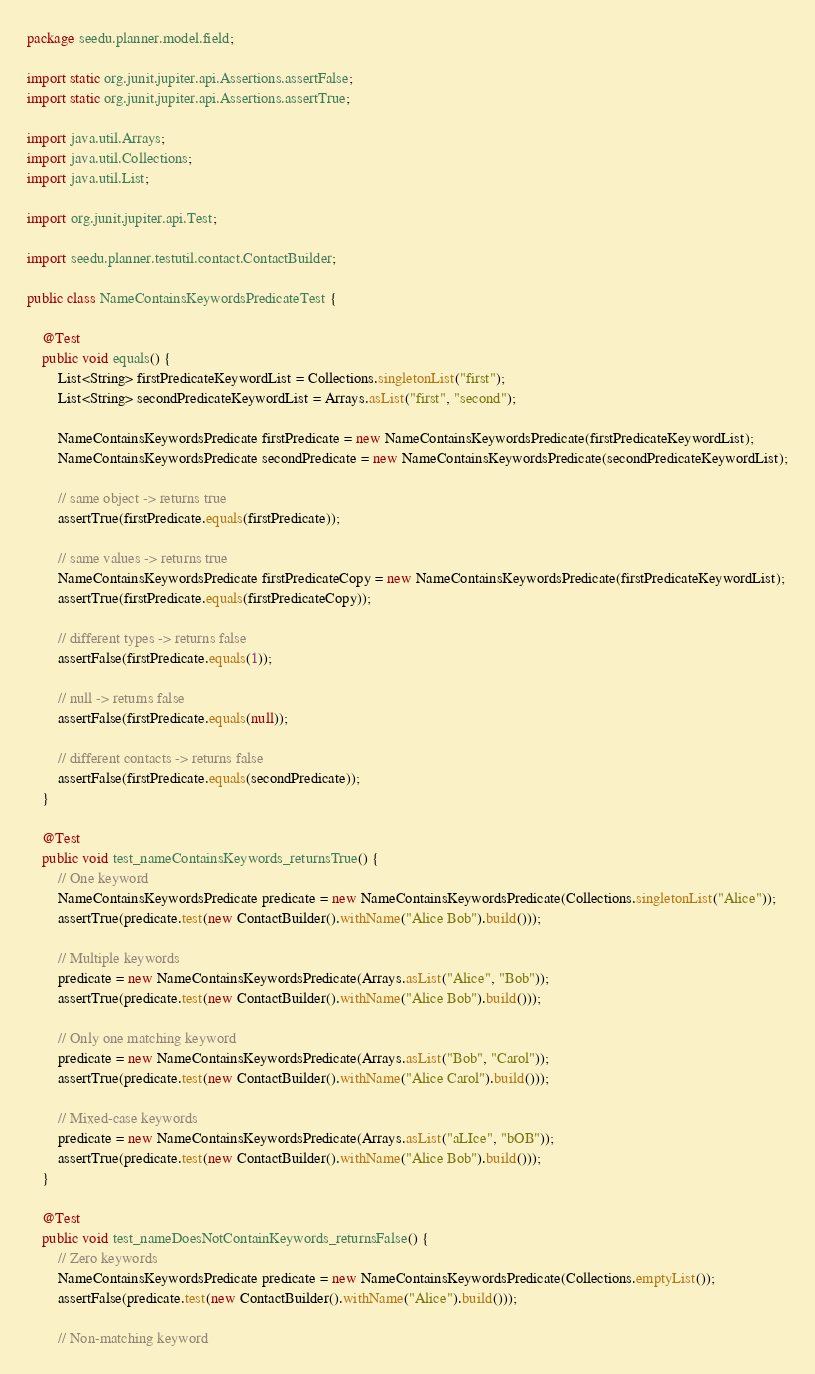Convert code to text. <code><loc_0><loc_0><loc_500><loc_500><_Java_>package seedu.planner.model.field;

import static org.junit.jupiter.api.Assertions.assertFalse;
import static org.junit.jupiter.api.Assertions.assertTrue;

import java.util.Arrays;
import java.util.Collections;
import java.util.List;

import org.junit.jupiter.api.Test;

import seedu.planner.testutil.contact.ContactBuilder;

public class NameContainsKeywordsPredicateTest {

    @Test
    public void equals() {
        List<String> firstPredicateKeywordList = Collections.singletonList("first");
        List<String> secondPredicateKeywordList = Arrays.asList("first", "second");

        NameContainsKeywordsPredicate firstPredicate = new NameContainsKeywordsPredicate(firstPredicateKeywordList);
        NameContainsKeywordsPredicate secondPredicate = new NameContainsKeywordsPredicate(secondPredicateKeywordList);

        // same object -> returns true
        assertTrue(firstPredicate.equals(firstPredicate));

        // same values -> returns true
        NameContainsKeywordsPredicate firstPredicateCopy = new NameContainsKeywordsPredicate(firstPredicateKeywordList);
        assertTrue(firstPredicate.equals(firstPredicateCopy));

        // different types -> returns false
        assertFalse(firstPredicate.equals(1));

        // null -> returns false
        assertFalse(firstPredicate.equals(null));

        // different contacts -> returns false
        assertFalse(firstPredicate.equals(secondPredicate));
    }

    @Test
    public void test_nameContainsKeywords_returnsTrue() {
        // One keyword
        NameContainsKeywordsPredicate predicate = new NameContainsKeywordsPredicate(Collections.singletonList("Alice"));
        assertTrue(predicate.test(new ContactBuilder().withName("Alice Bob").build()));

        // Multiple keywords
        predicate = new NameContainsKeywordsPredicate(Arrays.asList("Alice", "Bob"));
        assertTrue(predicate.test(new ContactBuilder().withName("Alice Bob").build()));

        // Only one matching keyword
        predicate = new NameContainsKeywordsPredicate(Arrays.asList("Bob", "Carol"));
        assertTrue(predicate.test(new ContactBuilder().withName("Alice Carol").build()));

        // Mixed-case keywords
        predicate = new NameContainsKeywordsPredicate(Arrays.asList("aLIce", "bOB"));
        assertTrue(predicate.test(new ContactBuilder().withName("Alice Bob").build()));
    }

    @Test
    public void test_nameDoesNotContainKeywords_returnsFalse() {
        // Zero keywords
        NameContainsKeywordsPredicate predicate = new NameContainsKeywordsPredicate(Collections.emptyList());
        assertFalse(predicate.test(new ContactBuilder().withName("Alice").build()));

        // Non-matching keyword</code> 